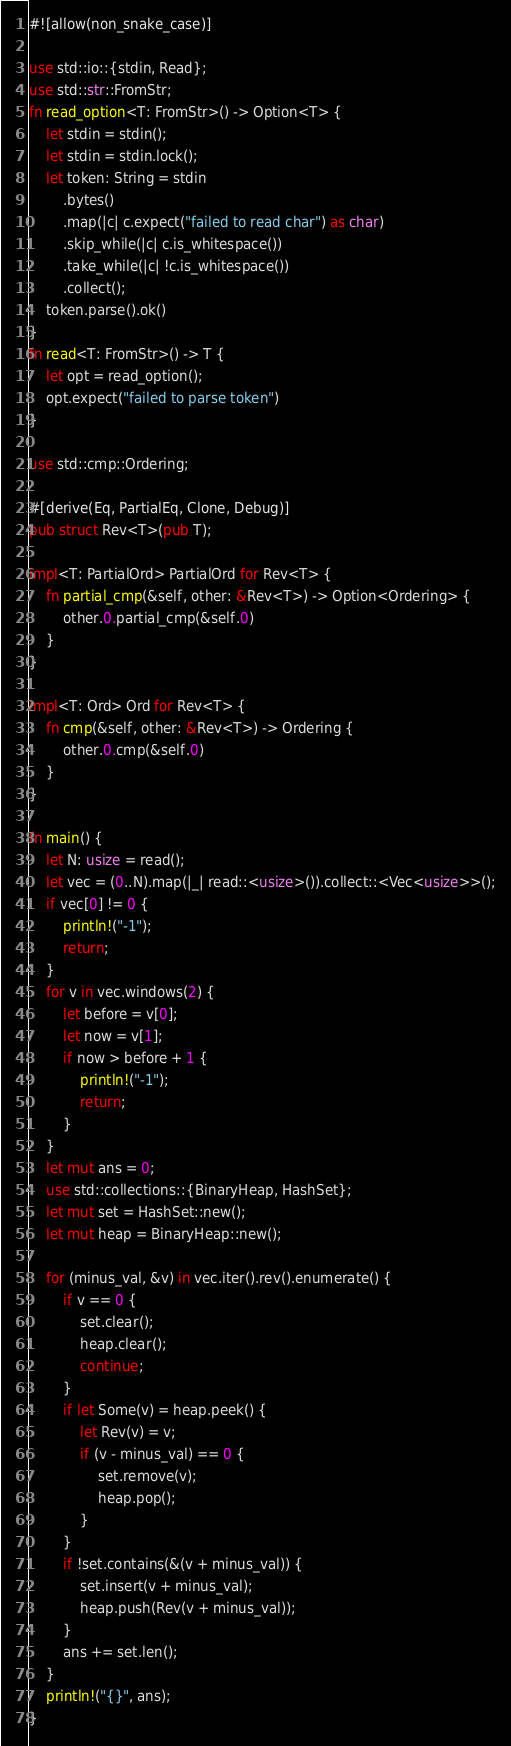Convert code to text. <code><loc_0><loc_0><loc_500><loc_500><_Rust_>#![allow(non_snake_case)]

use std::io::{stdin, Read};
use std::str::FromStr;
fn read_option<T: FromStr>() -> Option<T> {
    let stdin = stdin();
    let stdin = stdin.lock();
    let token: String = stdin
        .bytes()
        .map(|c| c.expect("failed to read char") as char)
        .skip_while(|c| c.is_whitespace())
        .take_while(|c| !c.is_whitespace())
        .collect();
    token.parse().ok()
}
fn read<T: FromStr>() -> T {
    let opt = read_option();
    opt.expect("failed to parse token")
}

use std::cmp::Ordering;

#[derive(Eq, PartialEq, Clone, Debug)]
pub struct Rev<T>(pub T);

impl<T: PartialOrd> PartialOrd for Rev<T> {
    fn partial_cmp(&self, other: &Rev<T>) -> Option<Ordering> {
        other.0.partial_cmp(&self.0)
    }
}

impl<T: Ord> Ord for Rev<T> {
    fn cmp(&self, other: &Rev<T>) -> Ordering {
        other.0.cmp(&self.0)
    }
}

fn main() {
    let N: usize = read();
    let vec = (0..N).map(|_| read::<usize>()).collect::<Vec<usize>>();
    if vec[0] != 0 {
        println!("-1");
        return;
    }
    for v in vec.windows(2) {
        let before = v[0];
        let now = v[1];
        if now > before + 1 {
            println!("-1");
            return;
        }
    }
    let mut ans = 0;
    use std::collections::{BinaryHeap, HashSet};
    let mut set = HashSet::new();
    let mut heap = BinaryHeap::new();

    for (minus_val, &v) in vec.iter().rev().enumerate() {
        if v == 0 {
            set.clear();
            heap.clear();
            continue;
        }
        if let Some(v) = heap.peek() {
            let Rev(v) = v;
            if (v - minus_val) == 0 {
                set.remove(v);
                heap.pop();
            }
        }
        if !set.contains(&(v + minus_val)) {
            set.insert(v + minus_val);
            heap.push(Rev(v + minus_val));
        }
        ans += set.len();
    }
    println!("{}", ans);
}
</code> 